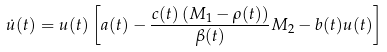<formula> <loc_0><loc_0><loc_500><loc_500>\dot { u } ( t ) = u ( t ) \left [ a ( t ) - \frac { c ( t ) \left ( M _ { 1 } - \rho ( t ) \right ) } { \beta ( t ) } M _ { 2 } - b ( t ) u ( t ) \right ]</formula> 